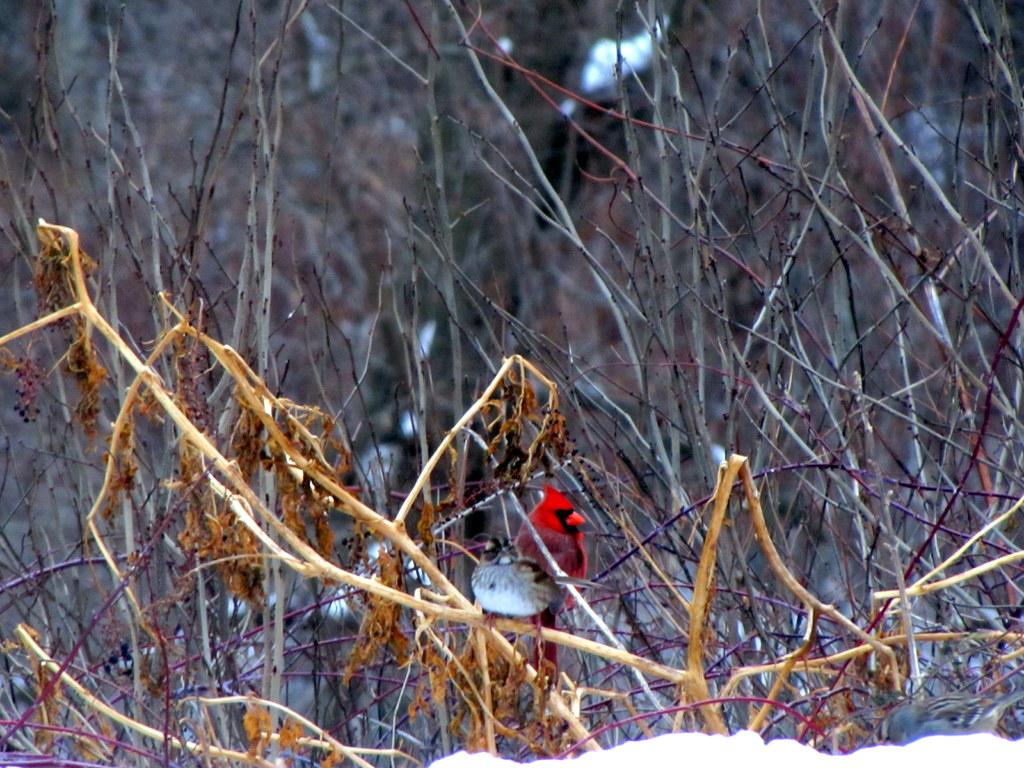What is the primary feature of the image? The primary feature of the image is the presence of many sticks. What type of natural environment is depicted in the image? The image shows a snowy environment, as snow is visible at the bottom of the image. How many cacti can be seen in the image? There are no cacti present in the image; it features sticks and snow. What method is used to sort the sticks in the image? There is no indication in the image that the sticks are being sorted, so it cannot be determined from the picture. 